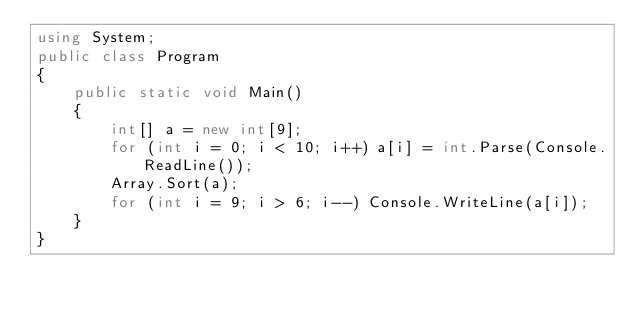<code> <loc_0><loc_0><loc_500><loc_500><_C#_>using System;
public class Program
{
    public static void Main()
    {
        int[] a = new int[9];
        for (int i = 0; i < 10; i++) a[i] = int.Parse(Console.ReadLine());
        Array.Sort(a);
        for (int i = 9; i > 6; i--) Console.WriteLine(a[i]);
    }
}</code> 